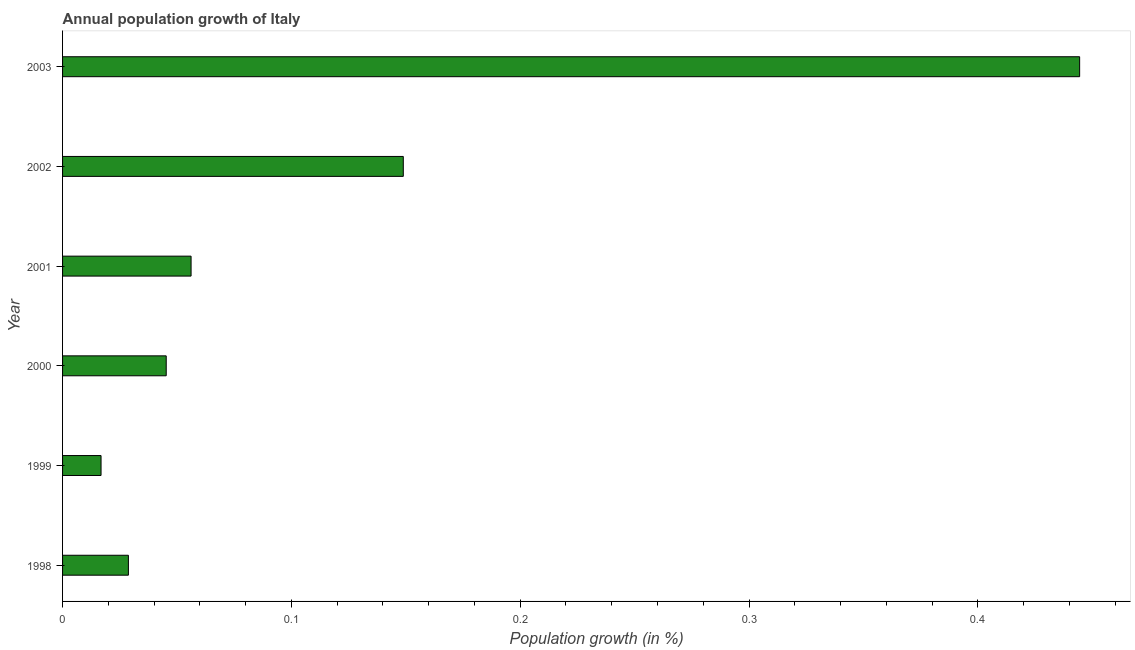Does the graph contain any zero values?
Give a very brief answer. No. What is the title of the graph?
Give a very brief answer. Annual population growth of Italy. What is the label or title of the X-axis?
Provide a short and direct response. Population growth (in %). What is the label or title of the Y-axis?
Ensure brevity in your answer.  Year. What is the population growth in 1999?
Offer a very short reply. 0.02. Across all years, what is the maximum population growth?
Your answer should be very brief. 0.44. Across all years, what is the minimum population growth?
Offer a very short reply. 0.02. What is the sum of the population growth?
Ensure brevity in your answer.  0.74. What is the difference between the population growth in 2002 and 2003?
Your answer should be very brief. -0.3. What is the average population growth per year?
Provide a short and direct response. 0.12. What is the median population growth?
Make the answer very short. 0.05. What is the ratio of the population growth in 2001 to that in 2003?
Offer a very short reply. 0.13. What is the difference between the highest and the second highest population growth?
Offer a very short reply. 0.3. Is the sum of the population growth in 1998 and 2002 greater than the maximum population growth across all years?
Offer a terse response. No. What is the difference between the highest and the lowest population growth?
Your response must be concise. 0.43. In how many years, is the population growth greater than the average population growth taken over all years?
Provide a short and direct response. 2. Are all the bars in the graph horizontal?
Your response must be concise. Yes. Are the values on the major ticks of X-axis written in scientific E-notation?
Offer a terse response. No. What is the Population growth (in %) of 1998?
Your answer should be compact. 0.03. What is the Population growth (in %) in 1999?
Your response must be concise. 0.02. What is the Population growth (in %) of 2000?
Your response must be concise. 0.05. What is the Population growth (in %) of 2001?
Keep it short and to the point. 0.06. What is the Population growth (in %) in 2002?
Your answer should be very brief. 0.15. What is the Population growth (in %) in 2003?
Provide a short and direct response. 0.44. What is the difference between the Population growth (in %) in 1998 and 1999?
Your response must be concise. 0.01. What is the difference between the Population growth (in %) in 1998 and 2000?
Ensure brevity in your answer.  -0.02. What is the difference between the Population growth (in %) in 1998 and 2001?
Provide a short and direct response. -0.03. What is the difference between the Population growth (in %) in 1998 and 2002?
Make the answer very short. -0.12. What is the difference between the Population growth (in %) in 1998 and 2003?
Your answer should be very brief. -0.42. What is the difference between the Population growth (in %) in 1999 and 2000?
Your answer should be very brief. -0.03. What is the difference between the Population growth (in %) in 1999 and 2001?
Give a very brief answer. -0.04. What is the difference between the Population growth (in %) in 1999 and 2002?
Provide a succinct answer. -0.13. What is the difference between the Population growth (in %) in 1999 and 2003?
Ensure brevity in your answer.  -0.43. What is the difference between the Population growth (in %) in 2000 and 2001?
Offer a terse response. -0.01. What is the difference between the Population growth (in %) in 2000 and 2002?
Your answer should be very brief. -0.1. What is the difference between the Population growth (in %) in 2000 and 2003?
Give a very brief answer. -0.4. What is the difference between the Population growth (in %) in 2001 and 2002?
Your response must be concise. -0.09. What is the difference between the Population growth (in %) in 2001 and 2003?
Provide a succinct answer. -0.39. What is the difference between the Population growth (in %) in 2002 and 2003?
Provide a short and direct response. -0.3. What is the ratio of the Population growth (in %) in 1998 to that in 1999?
Your answer should be compact. 1.71. What is the ratio of the Population growth (in %) in 1998 to that in 2000?
Give a very brief answer. 0.64. What is the ratio of the Population growth (in %) in 1998 to that in 2001?
Your response must be concise. 0.51. What is the ratio of the Population growth (in %) in 1998 to that in 2002?
Offer a terse response. 0.19. What is the ratio of the Population growth (in %) in 1998 to that in 2003?
Give a very brief answer. 0.07. What is the ratio of the Population growth (in %) in 1999 to that in 2000?
Your answer should be compact. 0.37. What is the ratio of the Population growth (in %) in 1999 to that in 2001?
Provide a succinct answer. 0.3. What is the ratio of the Population growth (in %) in 1999 to that in 2002?
Ensure brevity in your answer.  0.11. What is the ratio of the Population growth (in %) in 1999 to that in 2003?
Provide a succinct answer. 0.04. What is the ratio of the Population growth (in %) in 2000 to that in 2001?
Offer a very short reply. 0.81. What is the ratio of the Population growth (in %) in 2000 to that in 2002?
Make the answer very short. 0.3. What is the ratio of the Population growth (in %) in 2000 to that in 2003?
Your response must be concise. 0.1. What is the ratio of the Population growth (in %) in 2001 to that in 2002?
Offer a terse response. 0.38. What is the ratio of the Population growth (in %) in 2001 to that in 2003?
Your response must be concise. 0.13. What is the ratio of the Population growth (in %) in 2002 to that in 2003?
Offer a terse response. 0.34. 